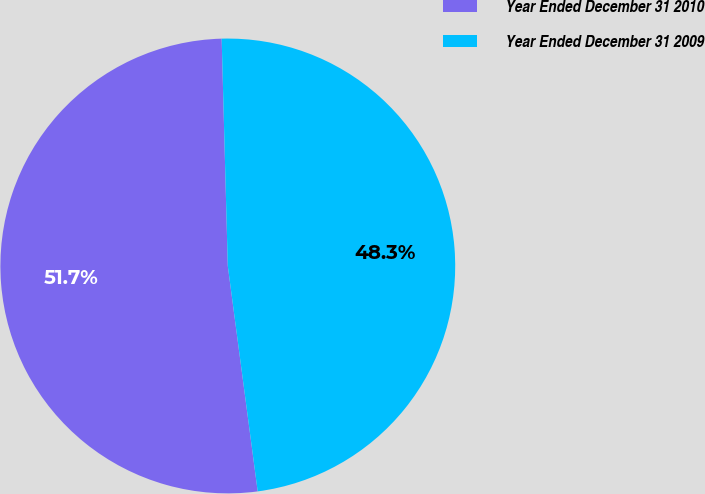Convert chart. <chart><loc_0><loc_0><loc_500><loc_500><pie_chart><fcel>Year Ended December 31 2010<fcel>Year Ended December 31 2009<nl><fcel>51.67%<fcel>48.33%<nl></chart> 